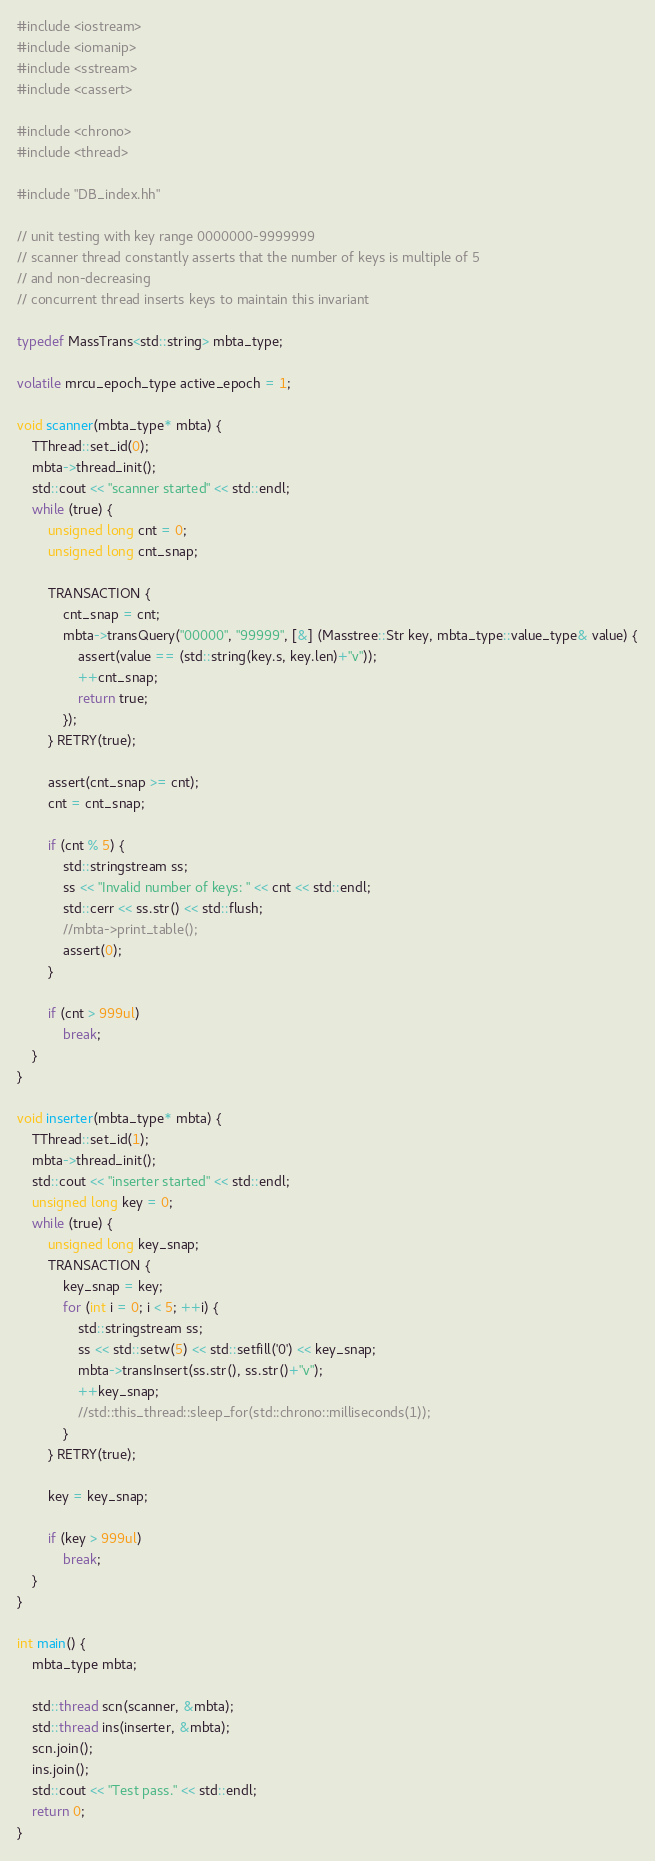Convert code to text. <code><loc_0><loc_0><loc_500><loc_500><_C++_>#include <iostream>
#include <iomanip>
#include <sstream>
#include <cassert>

#include <chrono>
#include <thread>

#include "DB_index.hh"

// unit testing with key range 0000000-9999999
// scanner thread constantly asserts that the number of keys is multiple of 5
// and non-decreasing
// concurrent thread inserts keys to maintain this invariant

typedef MassTrans<std::string> mbta_type;

volatile mrcu_epoch_type active_epoch = 1;

void scanner(mbta_type* mbta) {
    TThread::set_id(0);
    mbta->thread_init();
    std::cout << "scanner started" << std::endl;
    while (true) {
        unsigned long cnt = 0;
        unsigned long cnt_snap;

        TRANSACTION {
            cnt_snap = cnt;
            mbta->transQuery("00000", "99999", [&] (Masstree::Str key, mbta_type::value_type& value) {
                assert(value == (std::string(key.s, key.len)+"v"));
                ++cnt_snap;
                return true;
            });
        } RETRY(true);

        assert(cnt_snap >= cnt);
        cnt = cnt_snap;

        if (cnt % 5) {
            std::stringstream ss;
            ss << "Invalid number of keys: " << cnt << std::endl;
            std::cerr << ss.str() << std::flush;
            //mbta->print_table();
            assert(0);
        }

        if (cnt > 999ul)
            break;
    }
}

void inserter(mbta_type* mbta) {
    TThread::set_id(1);
    mbta->thread_init();
    std::cout << "inserter started" << std::endl;
    unsigned long key = 0;
    while (true) {
        unsigned long key_snap;
        TRANSACTION {
            key_snap = key;
            for (int i = 0; i < 5; ++i) {
                std::stringstream ss;
                ss << std::setw(5) << std::setfill('0') << key_snap;
                mbta->transInsert(ss.str(), ss.str()+"v");
                ++key_snap;
                //std::this_thread::sleep_for(std::chrono::milliseconds(1));
            }
        } RETRY(true);

        key = key_snap;

        if (key > 999ul)
            break;
    }
}

int main() {
    mbta_type mbta;

    std::thread scn(scanner, &mbta);
    std::thread ins(inserter, &mbta);
    scn.join();
    ins.join();
    std::cout << "Test pass." << std::endl;
    return 0;
}
</code> 